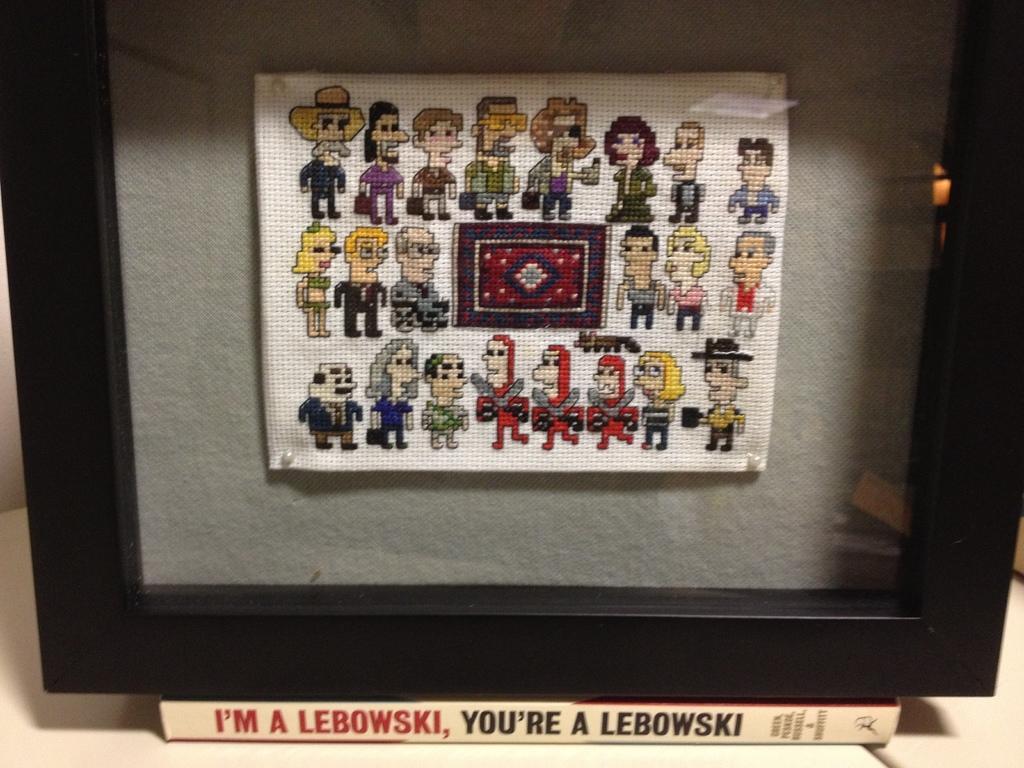Describe this image in one or two sentences. At the bottom of the image there is a white surface. In the middle of the image there is a frame with a paper on it and there are a few images on the paper. There is a book under the frame on the white surface. 